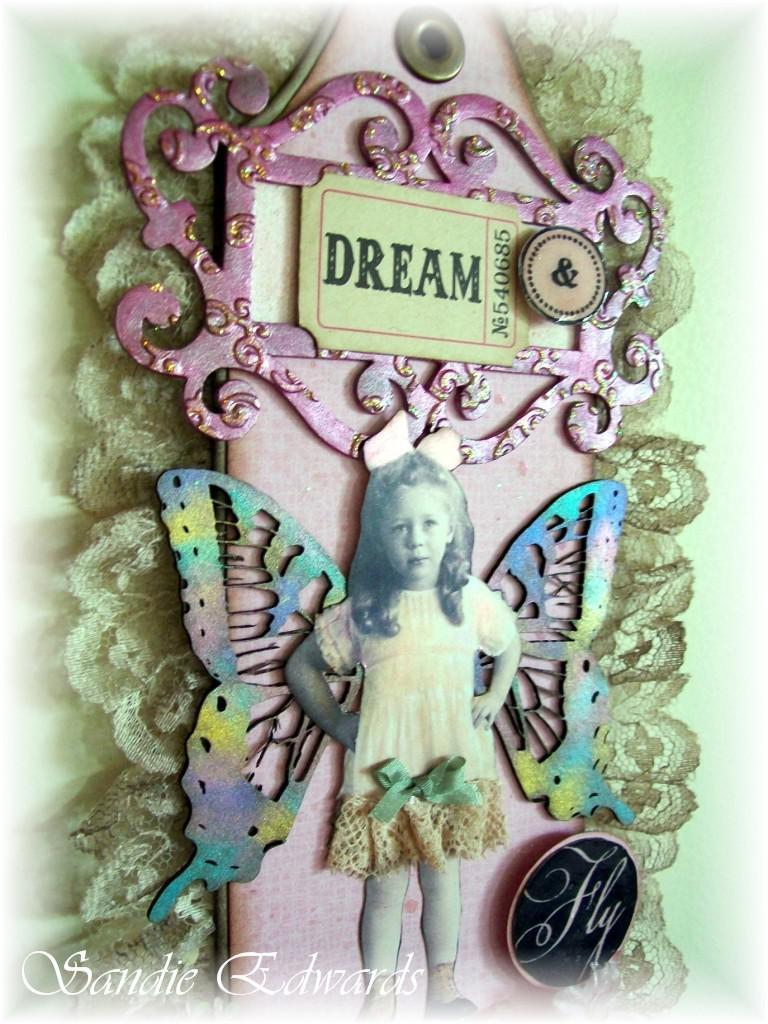<image>
Write a terse but informative summary of the picture. A piece of artwork featuring a little girl with butterfly wings and the word "dream" written on a ticket stub. 